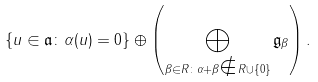<formula> <loc_0><loc_0><loc_500><loc_500>\{ u \in \mathfrak a \colon \alpha ( u ) = 0 \} \oplus \left ( \bigoplus _ { \beta \in R \colon \alpha + \beta \notin R \cup \{ 0 \} } \mathfrak g _ { \beta } \right ) .</formula> 